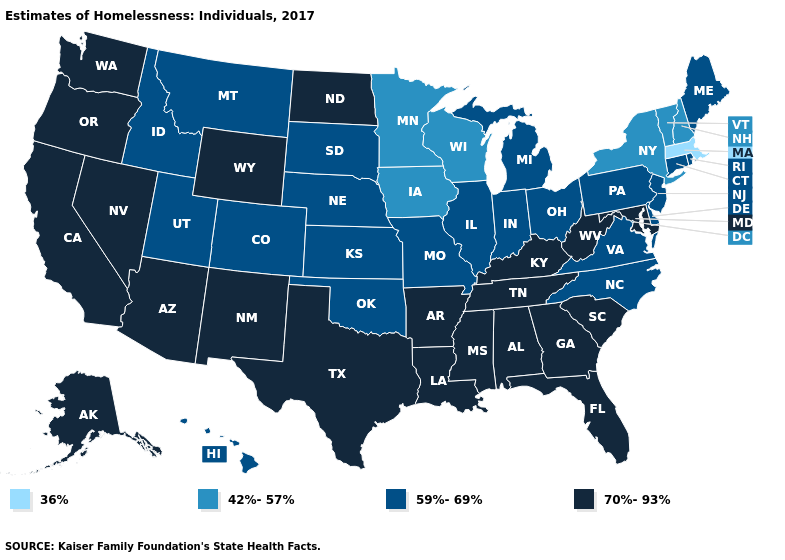Does Wyoming have a higher value than Indiana?
Short answer required. Yes. Does the map have missing data?
Give a very brief answer. No. Name the states that have a value in the range 42%-57%?
Give a very brief answer. Iowa, Minnesota, New Hampshire, New York, Vermont, Wisconsin. What is the value of Idaho?
Answer briefly. 59%-69%. Among the states that border South Carolina , which have the highest value?
Keep it brief. Georgia. What is the value of Oregon?
Quick response, please. 70%-93%. What is the value of Rhode Island?
Quick response, please. 59%-69%. Does North Dakota have a higher value than Vermont?
Be succinct. Yes. What is the value of Montana?
Short answer required. 59%-69%. What is the value of New York?
Give a very brief answer. 42%-57%. Which states have the lowest value in the Northeast?
Write a very short answer. Massachusetts. Name the states that have a value in the range 42%-57%?
Quick response, please. Iowa, Minnesota, New Hampshire, New York, Vermont, Wisconsin. What is the highest value in the West ?
Short answer required. 70%-93%. Does Massachusetts have the lowest value in the USA?
Short answer required. Yes. What is the highest value in the South ?
Short answer required. 70%-93%. 